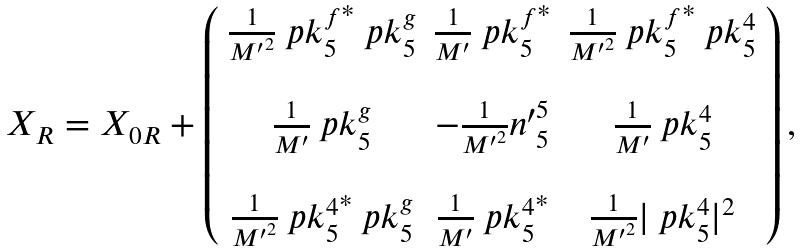Convert formula to latex. <formula><loc_0><loc_0><loc_500><loc_500>\begin{array} { l } X _ { R } = X _ { 0 R } + \left ( { \begin{array} { c c c } \frac { 1 } { { M ^ { \prime } } ^ { 2 } } { \ p k ^ { f } _ { 5 } } ^ { * } \ p k ^ { g } _ { 5 } & \frac { 1 } { M ^ { \prime } } { \ p k ^ { f } _ { 5 } } ^ { * } & \frac { 1 } { { M ^ { \prime } } ^ { 2 } } { \ p k ^ { f } _ { 5 } } ^ { * } \ p k ^ { 4 } _ { 5 } \\ & & \\ \frac { 1 } { M ^ { \prime } } \ p k ^ { g } _ { 5 } & - \frac { 1 } { { M ^ { \prime } } ^ { 2 } } { n ^ { \prime } } ^ { 5 } _ { 5 } & \frac { 1 } { M ^ { \prime } } \ p k ^ { 4 } _ { 5 } \\ & & \\ \frac { 1 } { { M ^ { \prime } } ^ { 2 } } { \ p k ^ { 4 } _ { 5 } } ^ { * } \ p k ^ { g } _ { 5 } & \frac { 1 } { M ^ { \prime } } { \ p k ^ { 4 } _ { 5 } } ^ { * } & \frac { 1 } { { M ^ { \prime } } ^ { 2 } } | \ p k ^ { 4 } _ { 5 } | ^ { 2 } \end{array} } \right ) , \\ \end{array}</formula> 